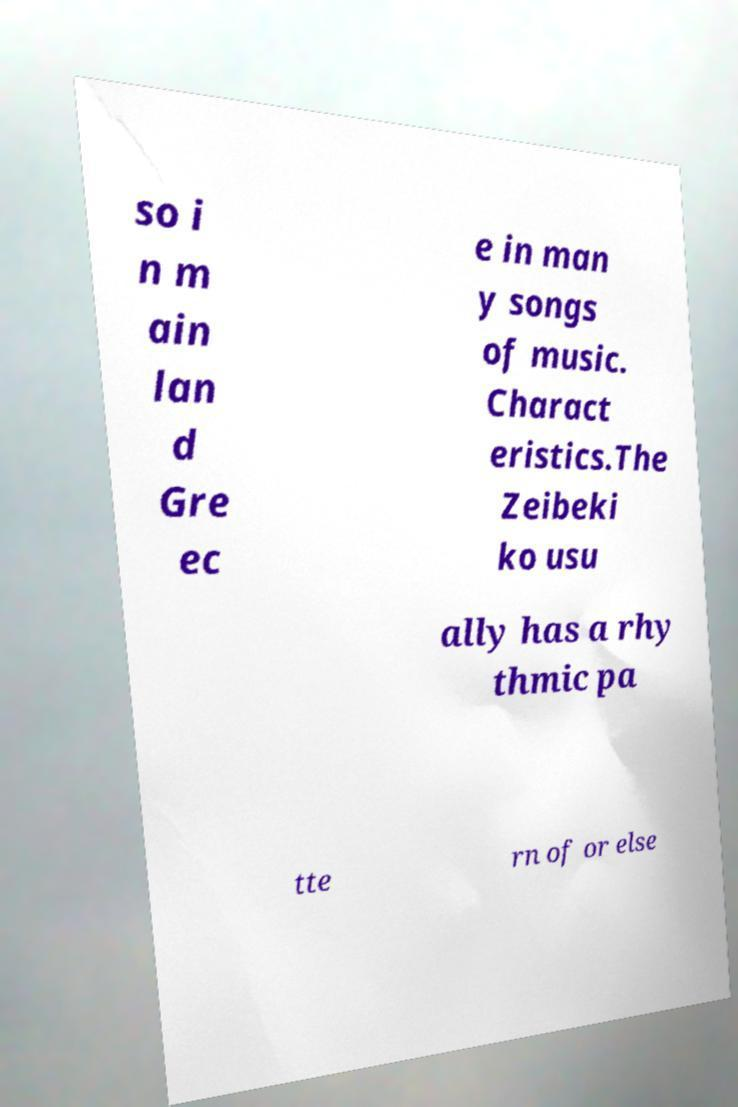Please identify and transcribe the text found in this image. so i n m ain lan d Gre ec e in man y songs of music. Charact eristics.The Zeibeki ko usu ally has a rhy thmic pa tte rn of or else 